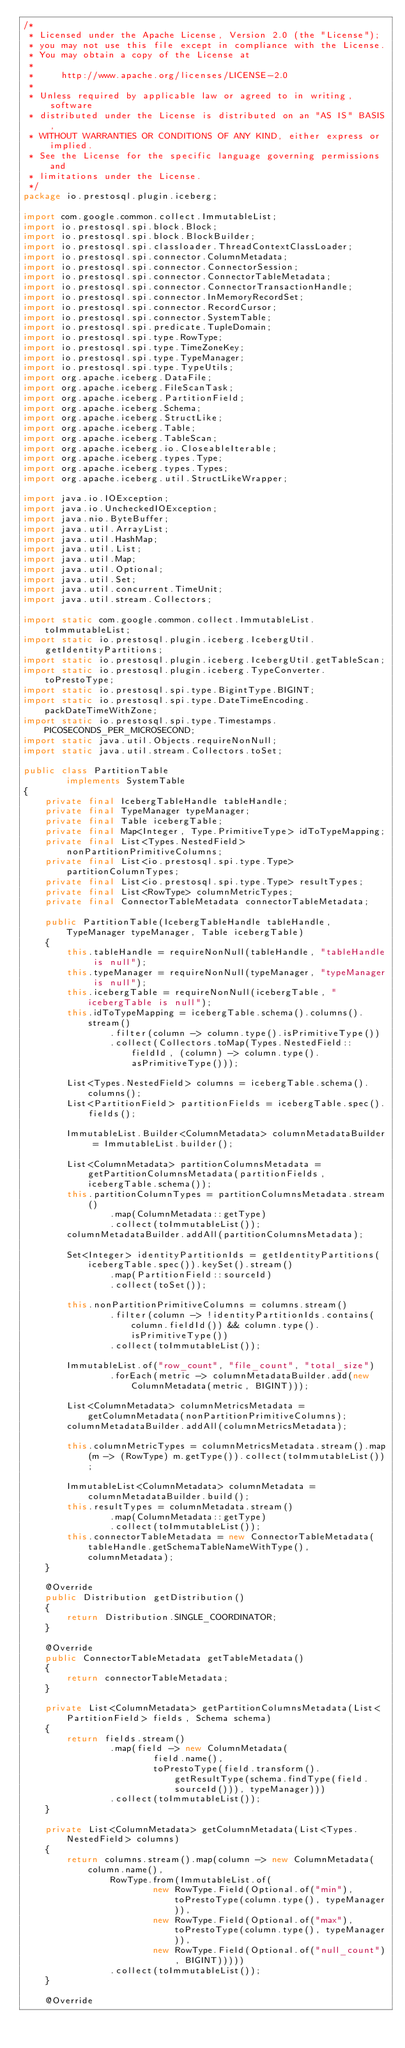<code> <loc_0><loc_0><loc_500><loc_500><_Java_>/*
 * Licensed under the Apache License, Version 2.0 (the "License");
 * you may not use this file except in compliance with the License.
 * You may obtain a copy of the License at
 *
 *     http://www.apache.org/licenses/LICENSE-2.0
 *
 * Unless required by applicable law or agreed to in writing, software
 * distributed under the License is distributed on an "AS IS" BASIS,
 * WITHOUT WARRANTIES OR CONDITIONS OF ANY KIND, either express or implied.
 * See the License for the specific language governing permissions and
 * limitations under the License.
 */
package io.prestosql.plugin.iceberg;

import com.google.common.collect.ImmutableList;
import io.prestosql.spi.block.Block;
import io.prestosql.spi.block.BlockBuilder;
import io.prestosql.spi.classloader.ThreadContextClassLoader;
import io.prestosql.spi.connector.ColumnMetadata;
import io.prestosql.spi.connector.ConnectorSession;
import io.prestosql.spi.connector.ConnectorTableMetadata;
import io.prestosql.spi.connector.ConnectorTransactionHandle;
import io.prestosql.spi.connector.InMemoryRecordSet;
import io.prestosql.spi.connector.RecordCursor;
import io.prestosql.spi.connector.SystemTable;
import io.prestosql.spi.predicate.TupleDomain;
import io.prestosql.spi.type.RowType;
import io.prestosql.spi.type.TimeZoneKey;
import io.prestosql.spi.type.TypeManager;
import io.prestosql.spi.type.TypeUtils;
import org.apache.iceberg.DataFile;
import org.apache.iceberg.FileScanTask;
import org.apache.iceberg.PartitionField;
import org.apache.iceberg.Schema;
import org.apache.iceberg.StructLike;
import org.apache.iceberg.Table;
import org.apache.iceberg.TableScan;
import org.apache.iceberg.io.CloseableIterable;
import org.apache.iceberg.types.Type;
import org.apache.iceberg.types.Types;
import org.apache.iceberg.util.StructLikeWrapper;

import java.io.IOException;
import java.io.UncheckedIOException;
import java.nio.ByteBuffer;
import java.util.ArrayList;
import java.util.HashMap;
import java.util.List;
import java.util.Map;
import java.util.Optional;
import java.util.Set;
import java.util.concurrent.TimeUnit;
import java.util.stream.Collectors;

import static com.google.common.collect.ImmutableList.toImmutableList;
import static io.prestosql.plugin.iceberg.IcebergUtil.getIdentityPartitions;
import static io.prestosql.plugin.iceberg.IcebergUtil.getTableScan;
import static io.prestosql.plugin.iceberg.TypeConverter.toPrestoType;
import static io.prestosql.spi.type.BigintType.BIGINT;
import static io.prestosql.spi.type.DateTimeEncoding.packDateTimeWithZone;
import static io.prestosql.spi.type.Timestamps.PICOSECONDS_PER_MICROSECOND;
import static java.util.Objects.requireNonNull;
import static java.util.stream.Collectors.toSet;

public class PartitionTable
        implements SystemTable
{
    private final IcebergTableHandle tableHandle;
    private final TypeManager typeManager;
    private final Table icebergTable;
    private final Map<Integer, Type.PrimitiveType> idToTypeMapping;
    private final List<Types.NestedField> nonPartitionPrimitiveColumns;
    private final List<io.prestosql.spi.type.Type> partitionColumnTypes;
    private final List<io.prestosql.spi.type.Type> resultTypes;
    private final List<RowType> columnMetricTypes;
    private final ConnectorTableMetadata connectorTableMetadata;

    public PartitionTable(IcebergTableHandle tableHandle, TypeManager typeManager, Table icebergTable)
    {
        this.tableHandle = requireNonNull(tableHandle, "tableHandle is null");
        this.typeManager = requireNonNull(typeManager, "typeManager is null");
        this.icebergTable = requireNonNull(icebergTable, "icebergTable is null");
        this.idToTypeMapping = icebergTable.schema().columns().stream()
                .filter(column -> column.type().isPrimitiveType())
                .collect(Collectors.toMap(Types.NestedField::fieldId, (column) -> column.type().asPrimitiveType()));

        List<Types.NestedField> columns = icebergTable.schema().columns();
        List<PartitionField> partitionFields = icebergTable.spec().fields();

        ImmutableList.Builder<ColumnMetadata> columnMetadataBuilder = ImmutableList.builder();

        List<ColumnMetadata> partitionColumnsMetadata = getPartitionColumnsMetadata(partitionFields, icebergTable.schema());
        this.partitionColumnTypes = partitionColumnsMetadata.stream()
                .map(ColumnMetadata::getType)
                .collect(toImmutableList());
        columnMetadataBuilder.addAll(partitionColumnsMetadata);

        Set<Integer> identityPartitionIds = getIdentityPartitions(icebergTable.spec()).keySet().stream()
                .map(PartitionField::sourceId)
                .collect(toSet());

        this.nonPartitionPrimitiveColumns = columns.stream()
                .filter(column -> !identityPartitionIds.contains(column.fieldId()) && column.type().isPrimitiveType())
                .collect(toImmutableList());

        ImmutableList.of("row_count", "file_count", "total_size")
                .forEach(metric -> columnMetadataBuilder.add(new ColumnMetadata(metric, BIGINT)));

        List<ColumnMetadata> columnMetricsMetadata = getColumnMetadata(nonPartitionPrimitiveColumns);
        columnMetadataBuilder.addAll(columnMetricsMetadata);

        this.columnMetricTypes = columnMetricsMetadata.stream().map(m -> (RowType) m.getType()).collect(toImmutableList());

        ImmutableList<ColumnMetadata> columnMetadata = columnMetadataBuilder.build();
        this.resultTypes = columnMetadata.stream()
                .map(ColumnMetadata::getType)
                .collect(toImmutableList());
        this.connectorTableMetadata = new ConnectorTableMetadata(tableHandle.getSchemaTableNameWithType(), columnMetadata);
    }

    @Override
    public Distribution getDistribution()
    {
        return Distribution.SINGLE_COORDINATOR;
    }

    @Override
    public ConnectorTableMetadata getTableMetadata()
    {
        return connectorTableMetadata;
    }

    private List<ColumnMetadata> getPartitionColumnsMetadata(List<PartitionField> fields, Schema schema)
    {
        return fields.stream()
                .map(field -> new ColumnMetadata(
                        field.name(),
                        toPrestoType(field.transform().getResultType(schema.findType(field.sourceId())), typeManager)))
                .collect(toImmutableList());
    }

    private List<ColumnMetadata> getColumnMetadata(List<Types.NestedField> columns)
    {
        return columns.stream().map(column -> new ColumnMetadata(column.name(),
                RowType.from(ImmutableList.of(
                        new RowType.Field(Optional.of("min"), toPrestoType(column.type(), typeManager)),
                        new RowType.Field(Optional.of("max"), toPrestoType(column.type(), typeManager)),
                        new RowType.Field(Optional.of("null_count"), BIGINT)))))
                .collect(toImmutableList());
    }

    @Override</code> 